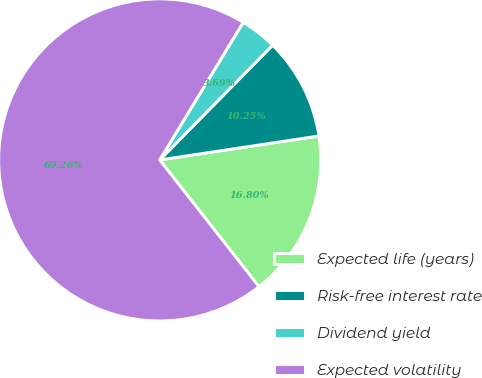<chart> <loc_0><loc_0><loc_500><loc_500><pie_chart><fcel>Expected life (years)<fcel>Risk-free interest rate<fcel>Dividend yield<fcel>Expected volatility<nl><fcel>16.8%<fcel>10.25%<fcel>3.69%<fcel>69.26%<nl></chart> 